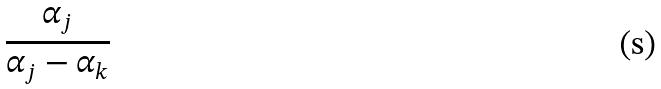Convert formula to latex. <formula><loc_0><loc_0><loc_500><loc_500>\frac { \alpha _ { j } } { \alpha _ { j } - \alpha _ { k } }</formula> 